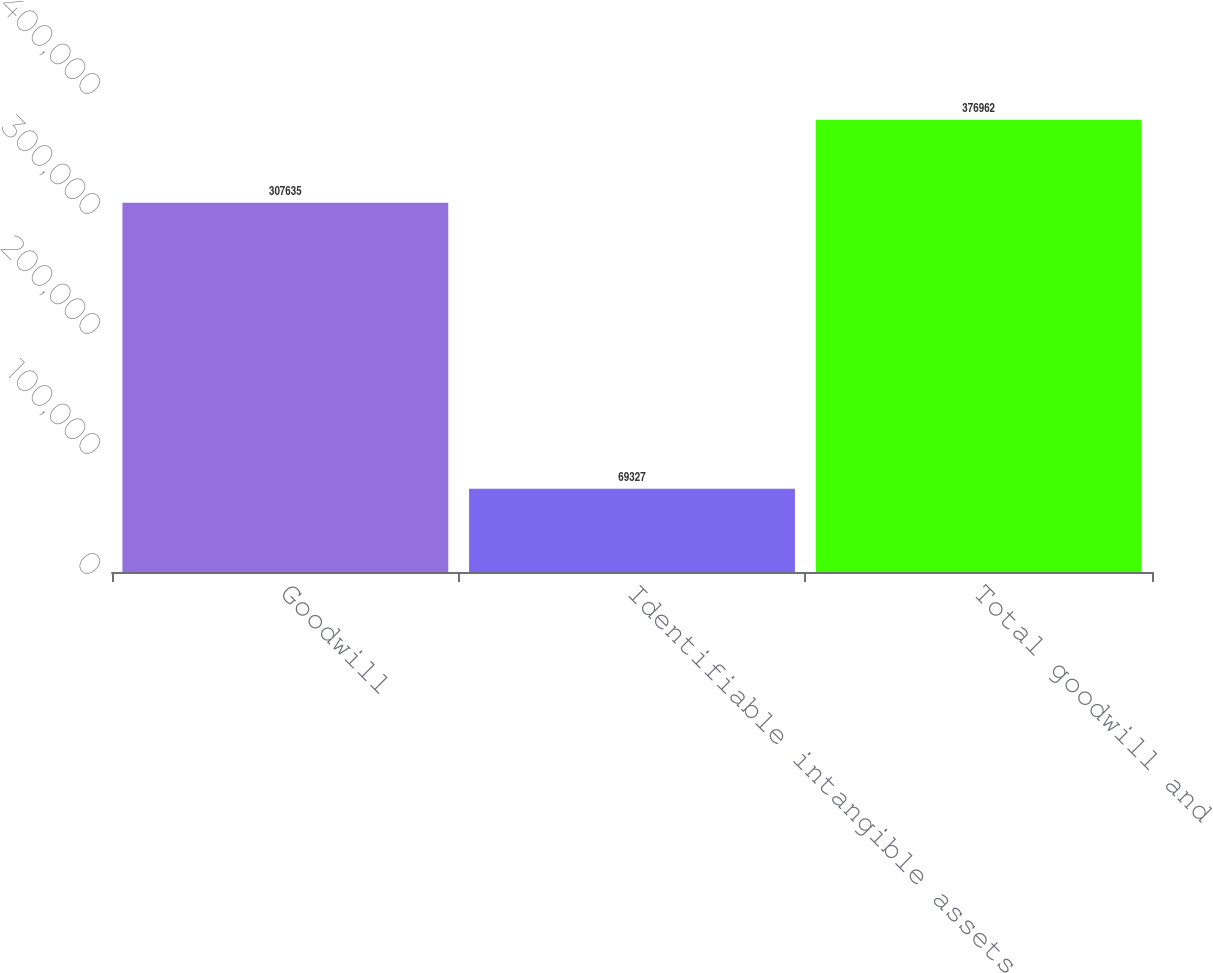Convert chart to OTSL. <chart><loc_0><loc_0><loc_500><loc_500><bar_chart><fcel>Goodwill<fcel>Identifiable intangible assets<fcel>Total goodwill and<nl><fcel>307635<fcel>69327<fcel>376962<nl></chart> 